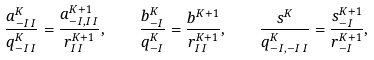Convert formula to latex. <formula><loc_0><loc_0><loc_500><loc_500>\frac { a ^ { K } _ { - I \, I } } { q ^ { K } _ { - I \, I } } = \frac { a ^ { K + 1 } _ { - I , I \, I } } { r ^ { K + 1 } _ { I \, I } } , \quad \frac { b ^ { K } _ { - I } } { q ^ { K } _ { - I } } = \frac { b ^ { K + 1 } } { r ^ { K + 1 } _ { I \, I } } , \quad \frac { s ^ { K } } { q ^ { K } _ { - I , - I \, I } } = \frac { s ^ { K + 1 } _ { - I } } { r ^ { K + 1 } _ { - I } } ,</formula> 